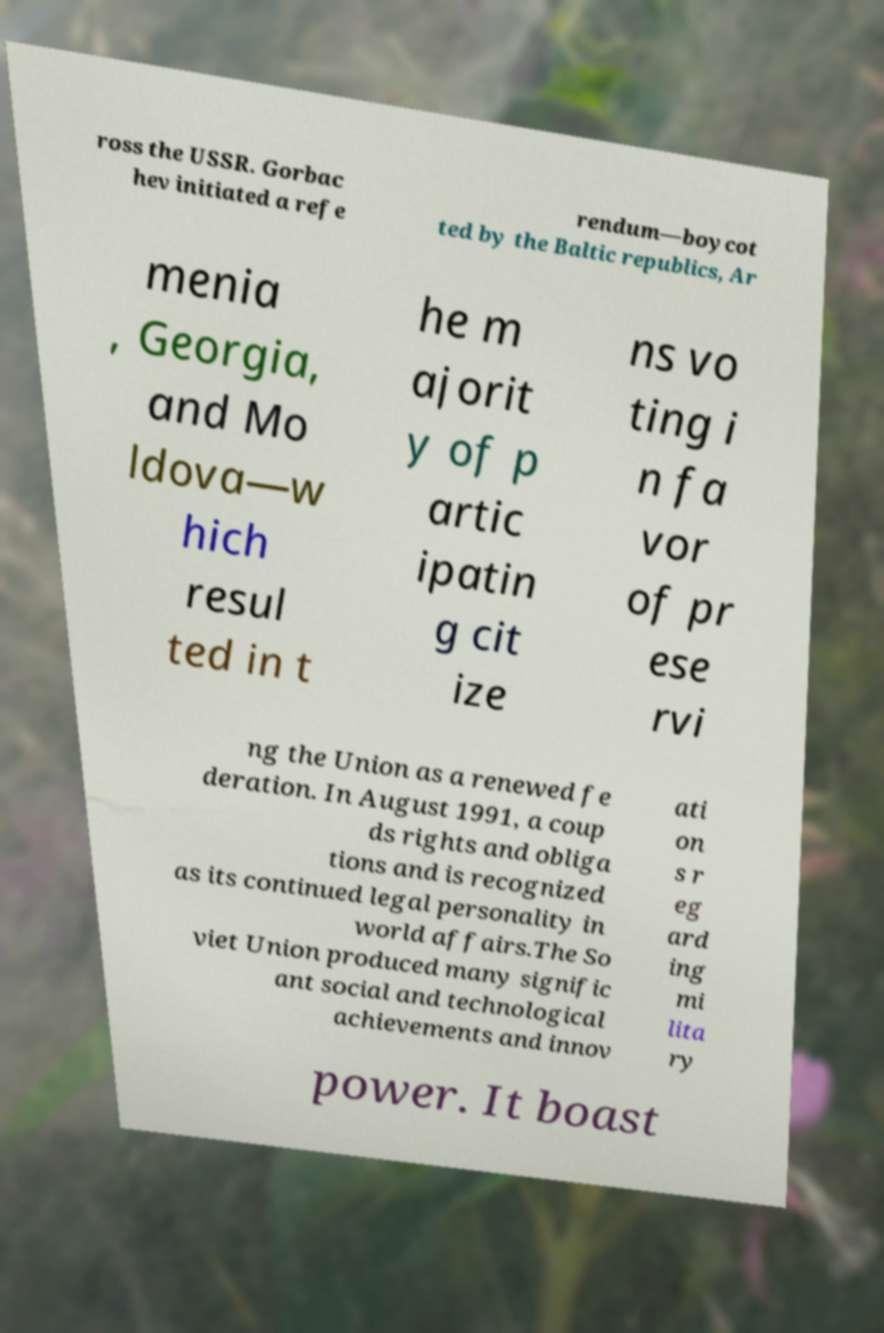Could you extract and type out the text from this image? ross the USSR. Gorbac hev initiated a refe rendum—boycot ted by the Baltic republics, Ar menia , Georgia, and Mo ldova—w hich resul ted in t he m ajorit y of p artic ipatin g cit ize ns vo ting i n fa vor of pr ese rvi ng the Union as a renewed fe deration. In August 1991, a coup ds rights and obliga tions and is recognized as its continued legal personality in world affairs.The So viet Union produced many signific ant social and technological achievements and innov ati on s r eg ard ing mi lita ry power. It boast 